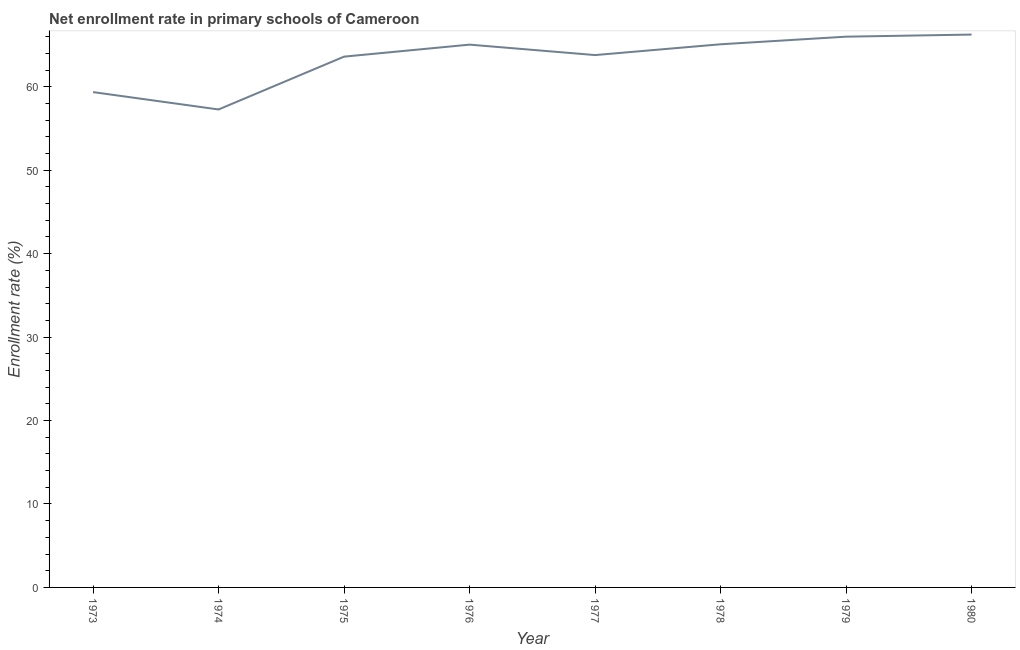What is the net enrollment rate in primary schools in 1977?
Ensure brevity in your answer.  63.8. Across all years, what is the maximum net enrollment rate in primary schools?
Make the answer very short. 66.26. Across all years, what is the minimum net enrollment rate in primary schools?
Offer a terse response. 57.28. In which year was the net enrollment rate in primary schools maximum?
Make the answer very short. 1980. In which year was the net enrollment rate in primary schools minimum?
Offer a terse response. 1974. What is the sum of the net enrollment rate in primary schools?
Keep it short and to the point. 506.46. What is the difference between the net enrollment rate in primary schools in 1977 and 1979?
Your answer should be very brief. -2.21. What is the average net enrollment rate in primary schools per year?
Offer a terse response. 63.31. What is the median net enrollment rate in primary schools?
Provide a short and direct response. 64.43. What is the ratio of the net enrollment rate in primary schools in 1974 to that in 1975?
Give a very brief answer. 0.9. What is the difference between the highest and the second highest net enrollment rate in primary schools?
Offer a very short reply. 0.25. Is the sum of the net enrollment rate in primary schools in 1975 and 1976 greater than the maximum net enrollment rate in primary schools across all years?
Offer a terse response. Yes. What is the difference between the highest and the lowest net enrollment rate in primary schools?
Give a very brief answer. 8.98. In how many years, is the net enrollment rate in primary schools greater than the average net enrollment rate in primary schools taken over all years?
Your response must be concise. 6. How many lines are there?
Make the answer very short. 1. How many years are there in the graph?
Ensure brevity in your answer.  8. What is the difference between two consecutive major ticks on the Y-axis?
Your answer should be compact. 10. Are the values on the major ticks of Y-axis written in scientific E-notation?
Provide a succinct answer. No. Does the graph contain grids?
Keep it short and to the point. No. What is the title of the graph?
Your answer should be very brief. Net enrollment rate in primary schools of Cameroon. What is the label or title of the Y-axis?
Offer a terse response. Enrollment rate (%). What is the Enrollment rate (%) in 1973?
Ensure brevity in your answer.  59.36. What is the Enrollment rate (%) in 1974?
Give a very brief answer. 57.28. What is the Enrollment rate (%) in 1975?
Offer a terse response. 63.61. What is the Enrollment rate (%) of 1976?
Your answer should be compact. 65.05. What is the Enrollment rate (%) of 1977?
Ensure brevity in your answer.  63.8. What is the Enrollment rate (%) in 1978?
Provide a short and direct response. 65.09. What is the Enrollment rate (%) of 1979?
Your answer should be very brief. 66.01. What is the Enrollment rate (%) in 1980?
Your answer should be very brief. 66.26. What is the difference between the Enrollment rate (%) in 1973 and 1974?
Ensure brevity in your answer.  2.08. What is the difference between the Enrollment rate (%) in 1973 and 1975?
Provide a short and direct response. -4.25. What is the difference between the Enrollment rate (%) in 1973 and 1976?
Your answer should be compact. -5.69. What is the difference between the Enrollment rate (%) in 1973 and 1977?
Provide a short and direct response. -4.44. What is the difference between the Enrollment rate (%) in 1973 and 1978?
Your answer should be very brief. -5.73. What is the difference between the Enrollment rate (%) in 1973 and 1979?
Offer a very short reply. -6.64. What is the difference between the Enrollment rate (%) in 1973 and 1980?
Provide a succinct answer. -6.89. What is the difference between the Enrollment rate (%) in 1974 and 1975?
Make the answer very short. -6.33. What is the difference between the Enrollment rate (%) in 1974 and 1976?
Make the answer very short. -7.77. What is the difference between the Enrollment rate (%) in 1974 and 1977?
Provide a succinct answer. -6.52. What is the difference between the Enrollment rate (%) in 1974 and 1978?
Keep it short and to the point. -7.81. What is the difference between the Enrollment rate (%) in 1974 and 1979?
Provide a short and direct response. -8.73. What is the difference between the Enrollment rate (%) in 1974 and 1980?
Give a very brief answer. -8.98. What is the difference between the Enrollment rate (%) in 1975 and 1976?
Your answer should be very brief. -1.44. What is the difference between the Enrollment rate (%) in 1975 and 1977?
Make the answer very short. -0.19. What is the difference between the Enrollment rate (%) in 1975 and 1978?
Offer a very short reply. -1.48. What is the difference between the Enrollment rate (%) in 1975 and 1979?
Keep it short and to the point. -2.39. What is the difference between the Enrollment rate (%) in 1975 and 1980?
Make the answer very short. -2.64. What is the difference between the Enrollment rate (%) in 1976 and 1977?
Make the answer very short. 1.25. What is the difference between the Enrollment rate (%) in 1976 and 1978?
Keep it short and to the point. -0.04. What is the difference between the Enrollment rate (%) in 1976 and 1979?
Make the answer very short. -0.95. What is the difference between the Enrollment rate (%) in 1976 and 1980?
Your answer should be very brief. -1.21. What is the difference between the Enrollment rate (%) in 1977 and 1978?
Provide a succinct answer. -1.29. What is the difference between the Enrollment rate (%) in 1977 and 1979?
Offer a very short reply. -2.21. What is the difference between the Enrollment rate (%) in 1977 and 1980?
Keep it short and to the point. -2.46. What is the difference between the Enrollment rate (%) in 1978 and 1979?
Make the answer very short. -0.91. What is the difference between the Enrollment rate (%) in 1978 and 1980?
Give a very brief answer. -1.16. What is the difference between the Enrollment rate (%) in 1979 and 1980?
Keep it short and to the point. -0.25. What is the ratio of the Enrollment rate (%) in 1973 to that in 1974?
Your answer should be compact. 1.04. What is the ratio of the Enrollment rate (%) in 1973 to that in 1975?
Offer a very short reply. 0.93. What is the ratio of the Enrollment rate (%) in 1973 to that in 1976?
Your answer should be compact. 0.91. What is the ratio of the Enrollment rate (%) in 1973 to that in 1977?
Provide a short and direct response. 0.93. What is the ratio of the Enrollment rate (%) in 1973 to that in 1978?
Your answer should be compact. 0.91. What is the ratio of the Enrollment rate (%) in 1973 to that in 1979?
Provide a succinct answer. 0.9. What is the ratio of the Enrollment rate (%) in 1973 to that in 1980?
Keep it short and to the point. 0.9. What is the ratio of the Enrollment rate (%) in 1974 to that in 1975?
Your answer should be very brief. 0.9. What is the ratio of the Enrollment rate (%) in 1974 to that in 1976?
Offer a terse response. 0.88. What is the ratio of the Enrollment rate (%) in 1974 to that in 1977?
Keep it short and to the point. 0.9. What is the ratio of the Enrollment rate (%) in 1974 to that in 1979?
Give a very brief answer. 0.87. What is the ratio of the Enrollment rate (%) in 1974 to that in 1980?
Your answer should be very brief. 0.86. What is the ratio of the Enrollment rate (%) in 1975 to that in 1976?
Keep it short and to the point. 0.98. What is the ratio of the Enrollment rate (%) in 1975 to that in 1979?
Offer a terse response. 0.96. What is the ratio of the Enrollment rate (%) in 1976 to that in 1977?
Provide a succinct answer. 1.02. What is the ratio of the Enrollment rate (%) in 1977 to that in 1978?
Give a very brief answer. 0.98. What is the ratio of the Enrollment rate (%) in 1977 to that in 1979?
Keep it short and to the point. 0.97. What is the ratio of the Enrollment rate (%) in 1977 to that in 1980?
Offer a very short reply. 0.96. What is the ratio of the Enrollment rate (%) in 1978 to that in 1979?
Make the answer very short. 0.99. What is the ratio of the Enrollment rate (%) in 1978 to that in 1980?
Your response must be concise. 0.98. 